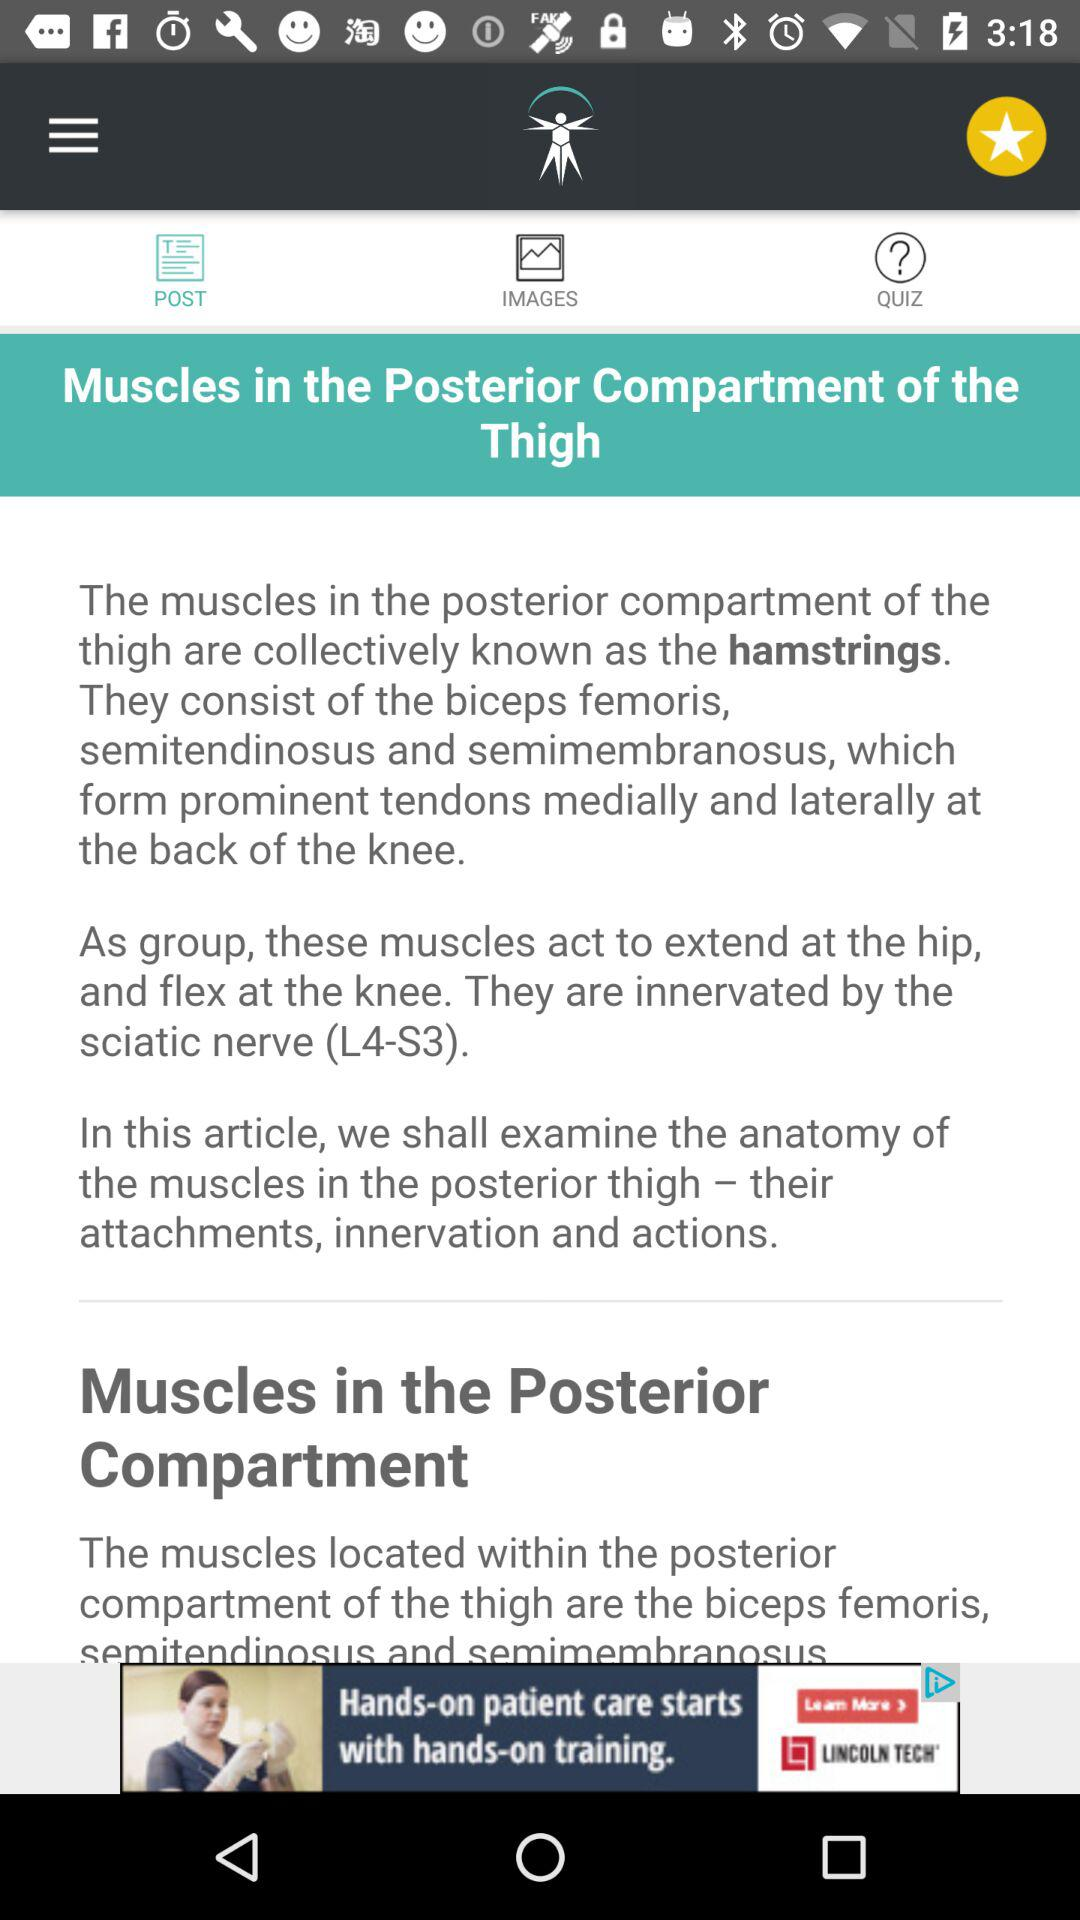How many muscles are located in the posterior compartment of the thigh?
Answer the question using a single word or phrase. 3 